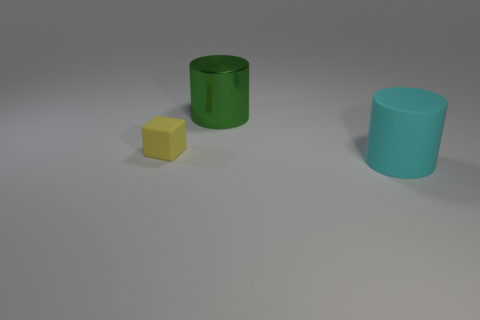Subtract 1 cylinders. How many cylinders are left? 1 Add 1 big red balls. How many objects exist? 4 Subtract all cyan cylinders. How many cylinders are left? 1 Subtract all gray cubes. Subtract all gray spheres. How many cubes are left? 1 Subtract all large cyan things. Subtract all yellow objects. How many objects are left? 1 Add 1 tiny yellow matte things. How many tiny yellow matte things are left? 2 Add 3 cyan rubber things. How many cyan rubber things exist? 4 Subtract 0 red blocks. How many objects are left? 3 Subtract all cylinders. How many objects are left? 1 